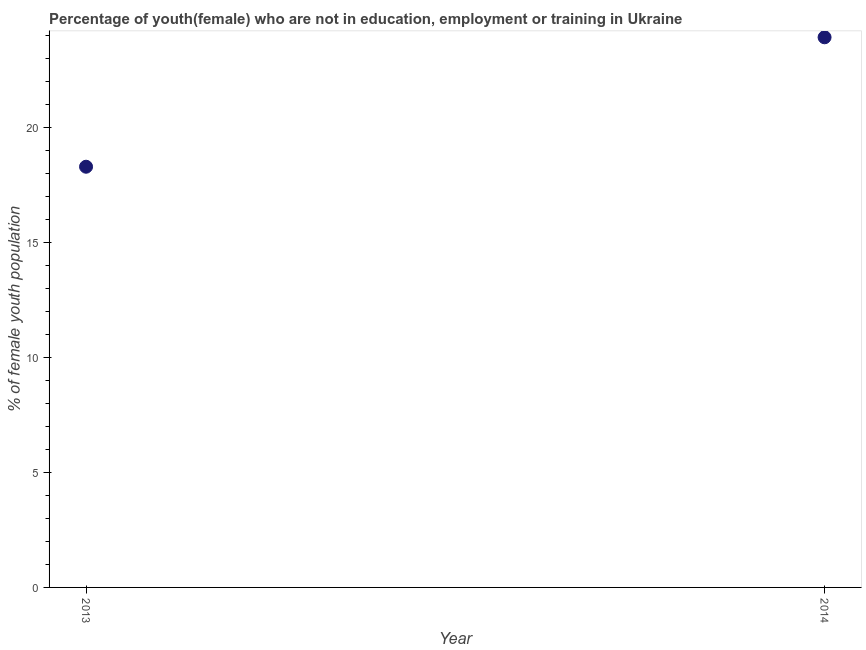What is the unemployed female youth population in 2014?
Offer a very short reply. 23.93. Across all years, what is the maximum unemployed female youth population?
Your response must be concise. 23.93. Across all years, what is the minimum unemployed female youth population?
Your answer should be very brief. 18.3. In which year was the unemployed female youth population minimum?
Your response must be concise. 2013. What is the sum of the unemployed female youth population?
Your response must be concise. 42.23. What is the difference between the unemployed female youth population in 2013 and 2014?
Your answer should be compact. -5.63. What is the average unemployed female youth population per year?
Keep it short and to the point. 21.11. What is the median unemployed female youth population?
Your answer should be compact. 21.11. What is the ratio of the unemployed female youth population in 2013 to that in 2014?
Ensure brevity in your answer.  0.76. Is the unemployed female youth population in 2013 less than that in 2014?
Offer a terse response. Yes. Does the unemployed female youth population monotonically increase over the years?
Your answer should be compact. Yes. How many dotlines are there?
Offer a terse response. 1. How many years are there in the graph?
Your answer should be compact. 2. What is the difference between two consecutive major ticks on the Y-axis?
Your response must be concise. 5. Are the values on the major ticks of Y-axis written in scientific E-notation?
Provide a short and direct response. No. What is the title of the graph?
Your response must be concise. Percentage of youth(female) who are not in education, employment or training in Ukraine. What is the label or title of the Y-axis?
Make the answer very short. % of female youth population. What is the % of female youth population in 2013?
Provide a succinct answer. 18.3. What is the % of female youth population in 2014?
Give a very brief answer. 23.93. What is the difference between the % of female youth population in 2013 and 2014?
Ensure brevity in your answer.  -5.63. What is the ratio of the % of female youth population in 2013 to that in 2014?
Your answer should be compact. 0.77. 